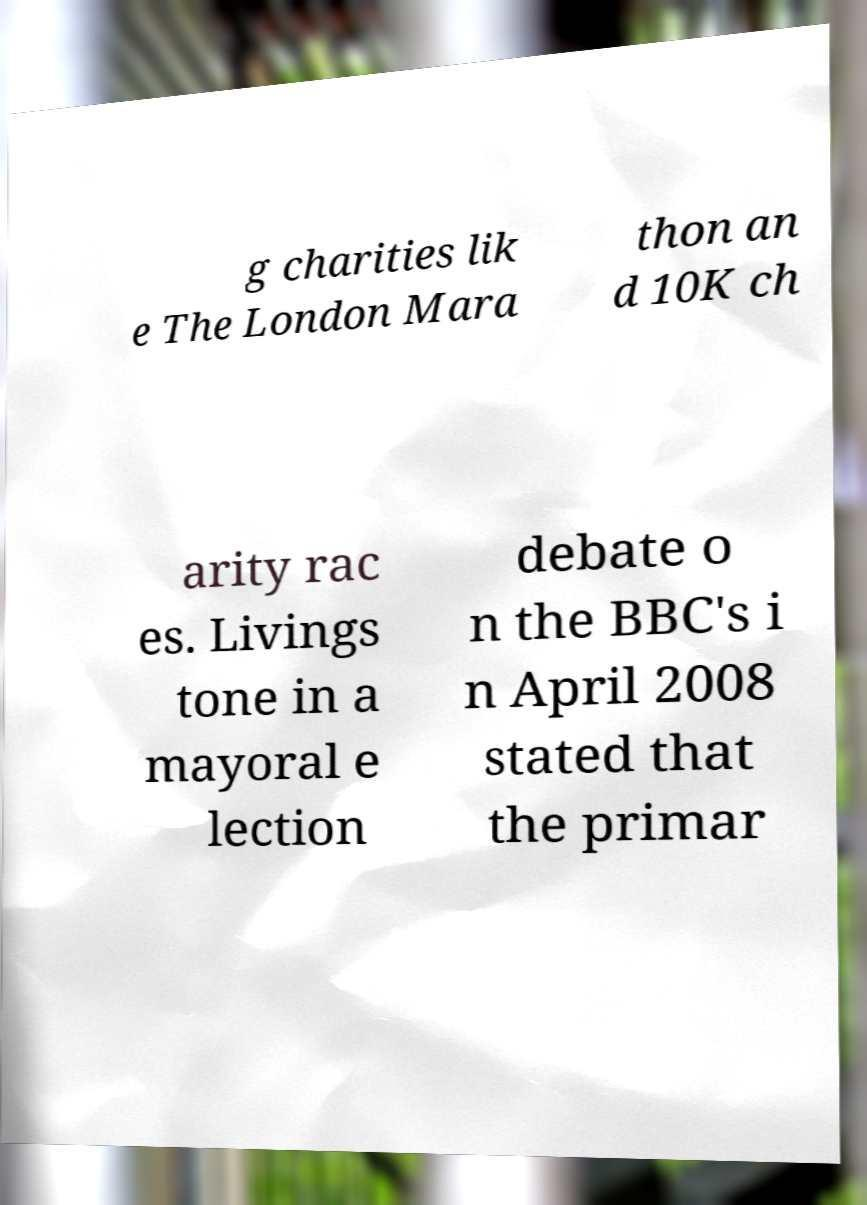Can you read and provide the text displayed in the image?This photo seems to have some interesting text. Can you extract and type it out for me? g charities lik e The London Mara thon an d 10K ch arity rac es. Livings tone in a mayoral e lection debate o n the BBC's i n April 2008 stated that the primar 